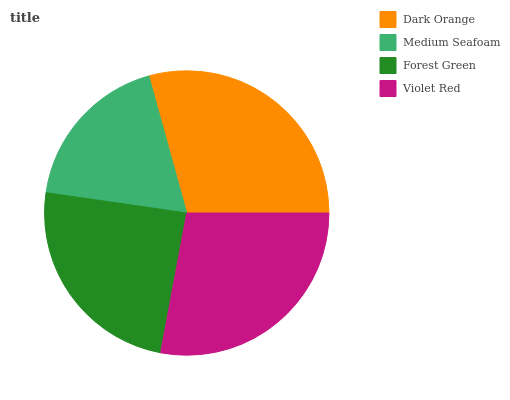Is Medium Seafoam the minimum?
Answer yes or no. Yes. Is Dark Orange the maximum?
Answer yes or no. Yes. Is Forest Green the minimum?
Answer yes or no. No. Is Forest Green the maximum?
Answer yes or no. No. Is Forest Green greater than Medium Seafoam?
Answer yes or no. Yes. Is Medium Seafoam less than Forest Green?
Answer yes or no. Yes. Is Medium Seafoam greater than Forest Green?
Answer yes or no. No. Is Forest Green less than Medium Seafoam?
Answer yes or no. No. Is Violet Red the high median?
Answer yes or no. Yes. Is Forest Green the low median?
Answer yes or no. Yes. Is Forest Green the high median?
Answer yes or no. No. Is Dark Orange the low median?
Answer yes or no. No. 